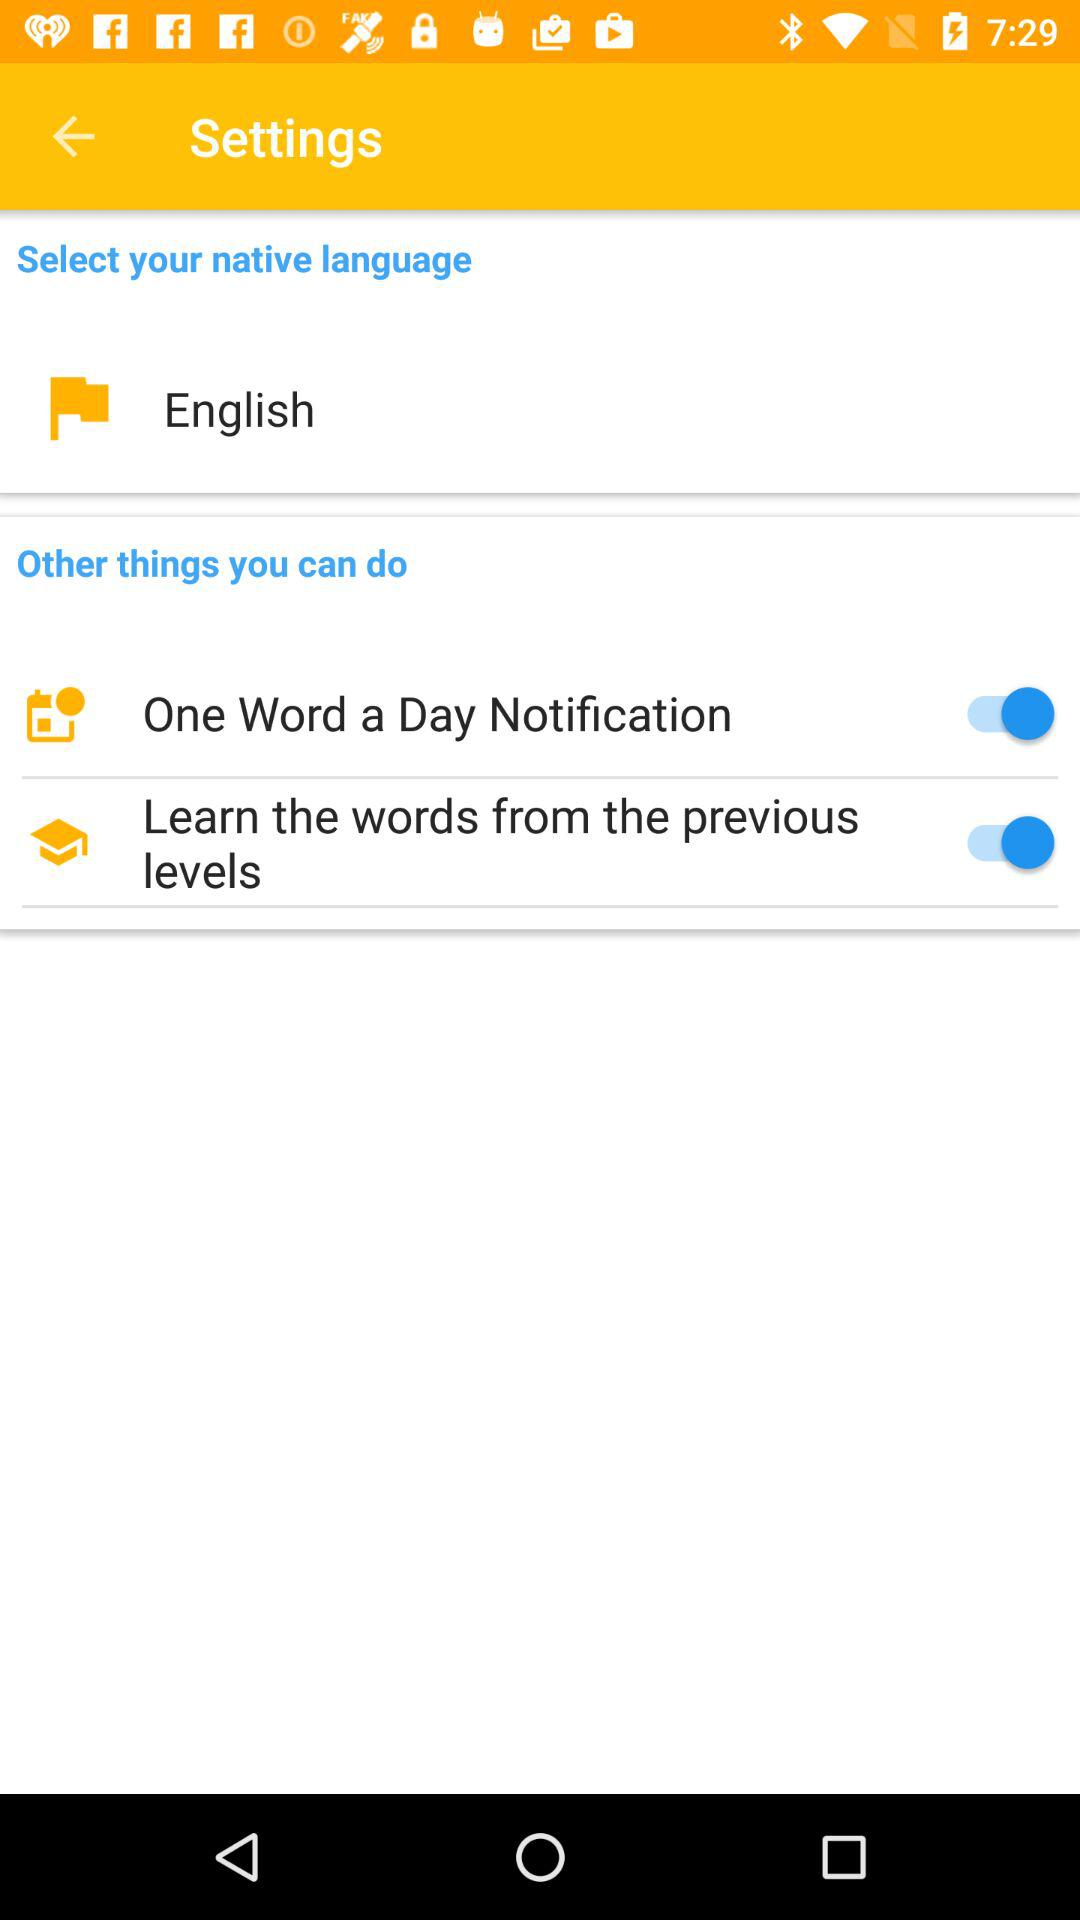How many more things can you do than select your native language?
Answer the question using a single word or phrase. 2 